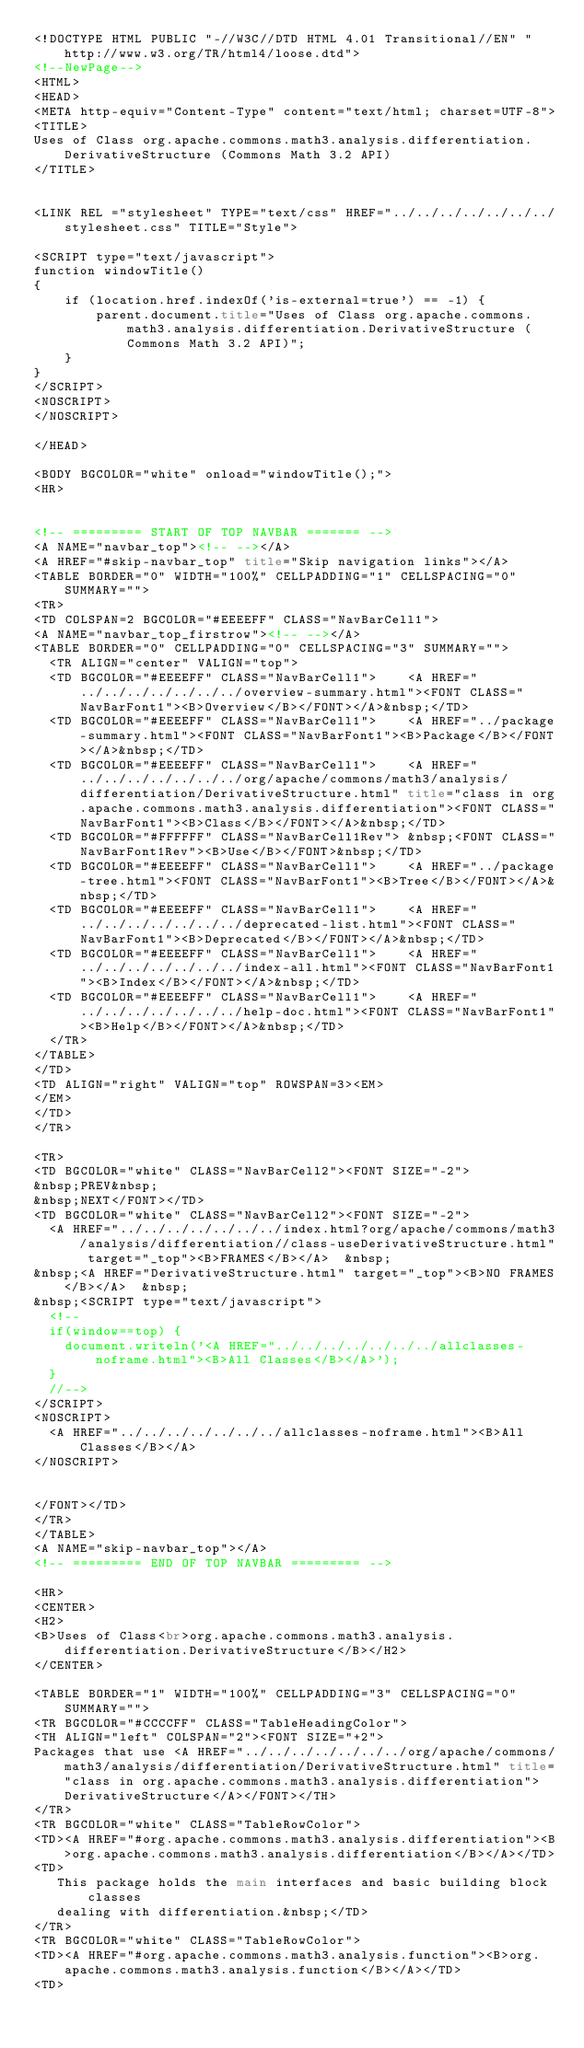<code> <loc_0><loc_0><loc_500><loc_500><_HTML_><!DOCTYPE HTML PUBLIC "-//W3C//DTD HTML 4.01 Transitional//EN" "http://www.w3.org/TR/html4/loose.dtd">
<!--NewPage-->
<HTML>
<HEAD>
<META http-equiv="Content-Type" content="text/html; charset=UTF-8">
<TITLE>
Uses of Class org.apache.commons.math3.analysis.differentiation.DerivativeStructure (Commons Math 3.2 API)
</TITLE>


<LINK REL ="stylesheet" TYPE="text/css" HREF="../../../../../../../stylesheet.css" TITLE="Style">

<SCRIPT type="text/javascript">
function windowTitle()
{
    if (location.href.indexOf('is-external=true') == -1) {
        parent.document.title="Uses of Class org.apache.commons.math3.analysis.differentiation.DerivativeStructure (Commons Math 3.2 API)";
    }
}
</SCRIPT>
<NOSCRIPT>
</NOSCRIPT>

</HEAD>

<BODY BGCOLOR="white" onload="windowTitle();">
<HR>


<!-- ========= START OF TOP NAVBAR ======= -->
<A NAME="navbar_top"><!-- --></A>
<A HREF="#skip-navbar_top" title="Skip navigation links"></A>
<TABLE BORDER="0" WIDTH="100%" CELLPADDING="1" CELLSPACING="0" SUMMARY="">
<TR>
<TD COLSPAN=2 BGCOLOR="#EEEEFF" CLASS="NavBarCell1">
<A NAME="navbar_top_firstrow"><!-- --></A>
<TABLE BORDER="0" CELLPADDING="0" CELLSPACING="3" SUMMARY="">
  <TR ALIGN="center" VALIGN="top">
  <TD BGCOLOR="#EEEEFF" CLASS="NavBarCell1">    <A HREF="../../../../../../../overview-summary.html"><FONT CLASS="NavBarFont1"><B>Overview</B></FONT></A>&nbsp;</TD>
  <TD BGCOLOR="#EEEEFF" CLASS="NavBarCell1">    <A HREF="../package-summary.html"><FONT CLASS="NavBarFont1"><B>Package</B></FONT></A>&nbsp;</TD>
  <TD BGCOLOR="#EEEEFF" CLASS="NavBarCell1">    <A HREF="../../../../../../../org/apache/commons/math3/analysis/differentiation/DerivativeStructure.html" title="class in org.apache.commons.math3.analysis.differentiation"><FONT CLASS="NavBarFont1"><B>Class</B></FONT></A>&nbsp;</TD>
  <TD BGCOLOR="#FFFFFF" CLASS="NavBarCell1Rev"> &nbsp;<FONT CLASS="NavBarFont1Rev"><B>Use</B></FONT>&nbsp;</TD>
  <TD BGCOLOR="#EEEEFF" CLASS="NavBarCell1">    <A HREF="../package-tree.html"><FONT CLASS="NavBarFont1"><B>Tree</B></FONT></A>&nbsp;</TD>
  <TD BGCOLOR="#EEEEFF" CLASS="NavBarCell1">    <A HREF="../../../../../../../deprecated-list.html"><FONT CLASS="NavBarFont1"><B>Deprecated</B></FONT></A>&nbsp;</TD>
  <TD BGCOLOR="#EEEEFF" CLASS="NavBarCell1">    <A HREF="../../../../../../../index-all.html"><FONT CLASS="NavBarFont1"><B>Index</B></FONT></A>&nbsp;</TD>
  <TD BGCOLOR="#EEEEFF" CLASS="NavBarCell1">    <A HREF="../../../../../../../help-doc.html"><FONT CLASS="NavBarFont1"><B>Help</B></FONT></A>&nbsp;</TD>
  </TR>
</TABLE>
</TD>
<TD ALIGN="right" VALIGN="top" ROWSPAN=3><EM>
</EM>
</TD>
</TR>

<TR>
<TD BGCOLOR="white" CLASS="NavBarCell2"><FONT SIZE="-2">
&nbsp;PREV&nbsp;
&nbsp;NEXT</FONT></TD>
<TD BGCOLOR="white" CLASS="NavBarCell2"><FONT SIZE="-2">
  <A HREF="../../../../../../../index.html?org/apache/commons/math3/analysis/differentiation//class-useDerivativeStructure.html" target="_top"><B>FRAMES</B></A>  &nbsp;
&nbsp;<A HREF="DerivativeStructure.html" target="_top"><B>NO FRAMES</B></A>  &nbsp;
&nbsp;<SCRIPT type="text/javascript">
  <!--
  if(window==top) {
    document.writeln('<A HREF="../../../../../../../allclasses-noframe.html"><B>All Classes</B></A>');
  }
  //-->
</SCRIPT>
<NOSCRIPT>
  <A HREF="../../../../../../../allclasses-noframe.html"><B>All Classes</B></A>
</NOSCRIPT>


</FONT></TD>
</TR>
</TABLE>
<A NAME="skip-navbar_top"></A>
<!-- ========= END OF TOP NAVBAR ========= -->

<HR>
<CENTER>
<H2>
<B>Uses of Class<br>org.apache.commons.math3.analysis.differentiation.DerivativeStructure</B></H2>
</CENTER>

<TABLE BORDER="1" WIDTH="100%" CELLPADDING="3" CELLSPACING="0" SUMMARY="">
<TR BGCOLOR="#CCCCFF" CLASS="TableHeadingColor">
<TH ALIGN="left" COLSPAN="2"><FONT SIZE="+2">
Packages that use <A HREF="../../../../../../../org/apache/commons/math3/analysis/differentiation/DerivativeStructure.html" title="class in org.apache.commons.math3.analysis.differentiation">DerivativeStructure</A></FONT></TH>
</TR>
<TR BGCOLOR="white" CLASS="TableRowColor">
<TD><A HREF="#org.apache.commons.math3.analysis.differentiation"><B>org.apache.commons.math3.analysis.differentiation</B></A></TD>
<TD>
   This package holds the main interfaces and basic building block classes
   dealing with differentiation.&nbsp;</TD>
</TR>
<TR BGCOLOR="white" CLASS="TableRowColor">
<TD><A HREF="#org.apache.commons.math3.analysis.function"><B>org.apache.commons.math3.analysis.function</B></A></TD>
<TD></code> 